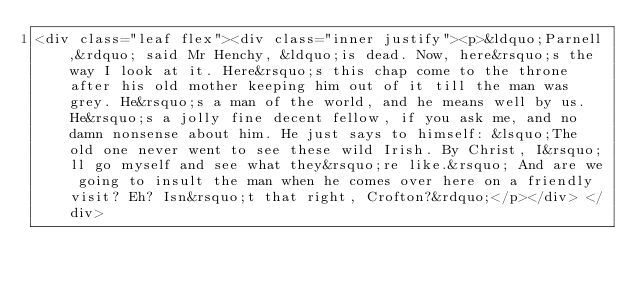<code> <loc_0><loc_0><loc_500><loc_500><_HTML_><div class="leaf flex"><div class="inner justify"><p>&ldquo;Parnell,&rdquo; said Mr Henchy, &ldquo;is dead. Now, here&rsquo;s the way I look at it. Here&rsquo;s this chap come to the throne after his old mother keeping him out of it till the man was grey. He&rsquo;s a man of the world, and he means well by us. He&rsquo;s a jolly fine decent fellow, if you ask me, and no damn nonsense about him. He just says to himself: &lsquo;The old one never went to see these wild Irish. By Christ, I&rsquo;ll go myself and see what they&rsquo;re like.&rsquo; And are we going to insult the man when he comes over here on a friendly visit? Eh? Isn&rsquo;t that right, Crofton?&rdquo;</p></div> </div></code> 